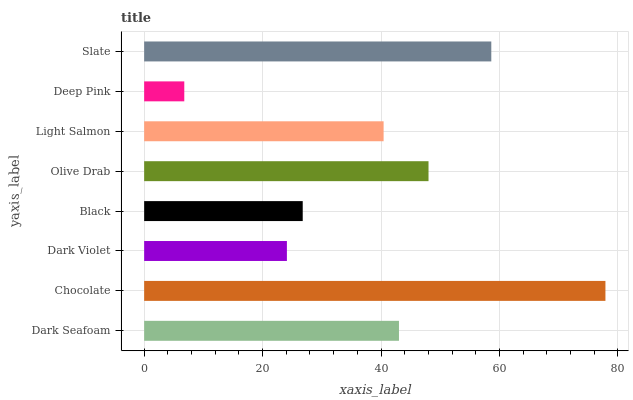Is Deep Pink the minimum?
Answer yes or no. Yes. Is Chocolate the maximum?
Answer yes or no. Yes. Is Dark Violet the minimum?
Answer yes or no. No. Is Dark Violet the maximum?
Answer yes or no. No. Is Chocolate greater than Dark Violet?
Answer yes or no. Yes. Is Dark Violet less than Chocolate?
Answer yes or no. Yes. Is Dark Violet greater than Chocolate?
Answer yes or no. No. Is Chocolate less than Dark Violet?
Answer yes or no. No. Is Dark Seafoam the high median?
Answer yes or no. Yes. Is Light Salmon the low median?
Answer yes or no. Yes. Is Black the high median?
Answer yes or no. No. Is Dark Seafoam the low median?
Answer yes or no. No. 